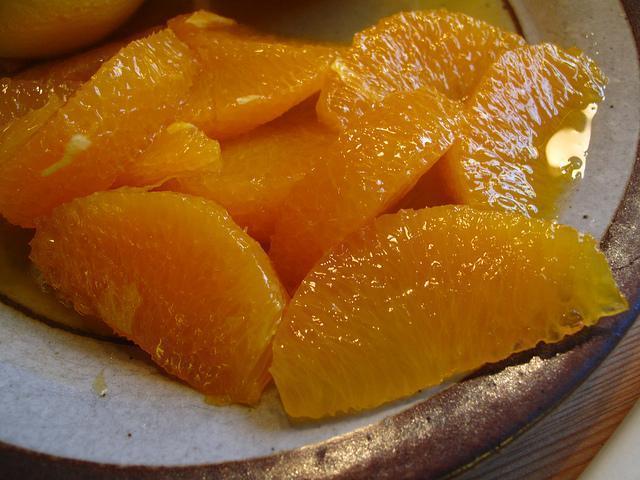How many different colors is the food?
Give a very brief answer. 1. How many oranges can you see?
Give a very brief answer. 5. 